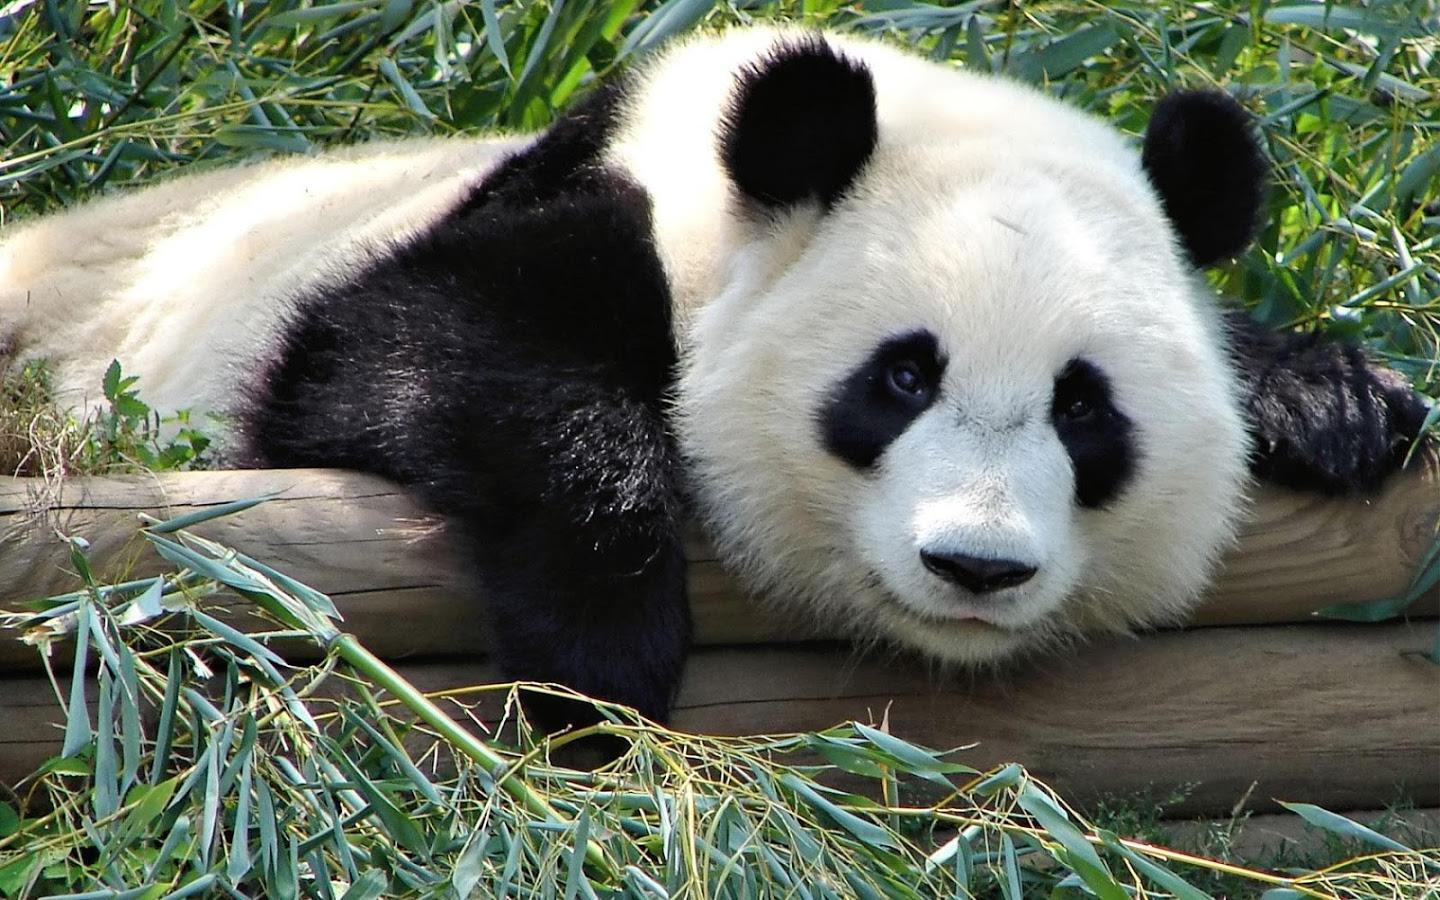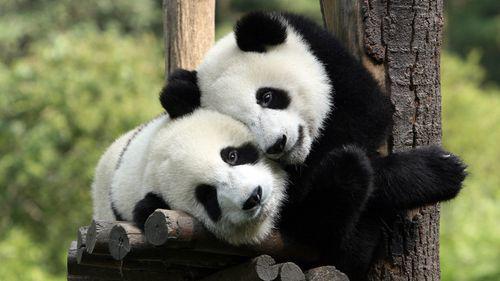The first image is the image on the left, the second image is the image on the right. Assess this claim about the two images: "The left and right image contains the same number of pandas sitting next to each other.". Correct or not? Answer yes or no. No. The first image is the image on the left, the second image is the image on the right. Assess this claim about the two images: "In one image, two pandas are sitting close together with at least one of them clutching a green stalk, and the other image shows two pandas with their bodies facing.". Correct or not? Answer yes or no. No. 